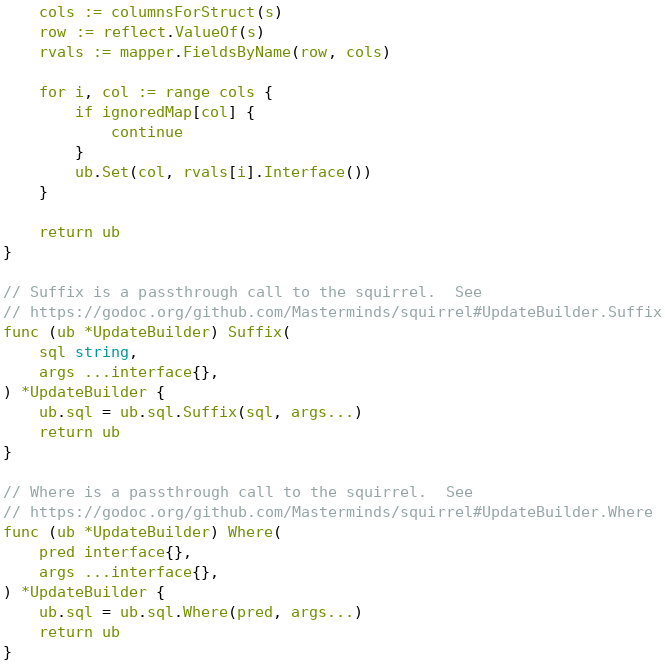<code> <loc_0><loc_0><loc_500><loc_500><_Go_>	cols := columnsForStruct(s)
	row := reflect.ValueOf(s)
	rvals := mapper.FieldsByName(row, cols)

	for i, col := range cols {
		if ignoredMap[col] {
			continue
		}
		ub.Set(col, rvals[i].Interface())
	}

	return ub
}

// Suffix is a passthrough call to the squirrel.  See
// https://godoc.org/github.com/Masterminds/squirrel#UpdateBuilder.Suffix
func (ub *UpdateBuilder) Suffix(
	sql string,
	args ...interface{},
) *UpdateBuilder {
	ub.sql = ub.sql.Suffix(sql, args...)
	return ub
}

// Where is a passthrough call to the squirrel.  See
// https://godoc.org/github.com/Masterminds/squirrel#UpdateBuilder.Where
func (ub *UpdateBuilder) Where(
	pred interface{},
	args ...interface{},
) *UpdateBuilder {
	ub.sql = ub.sql.Where(pred, args...)
	return ub
}
</code> 